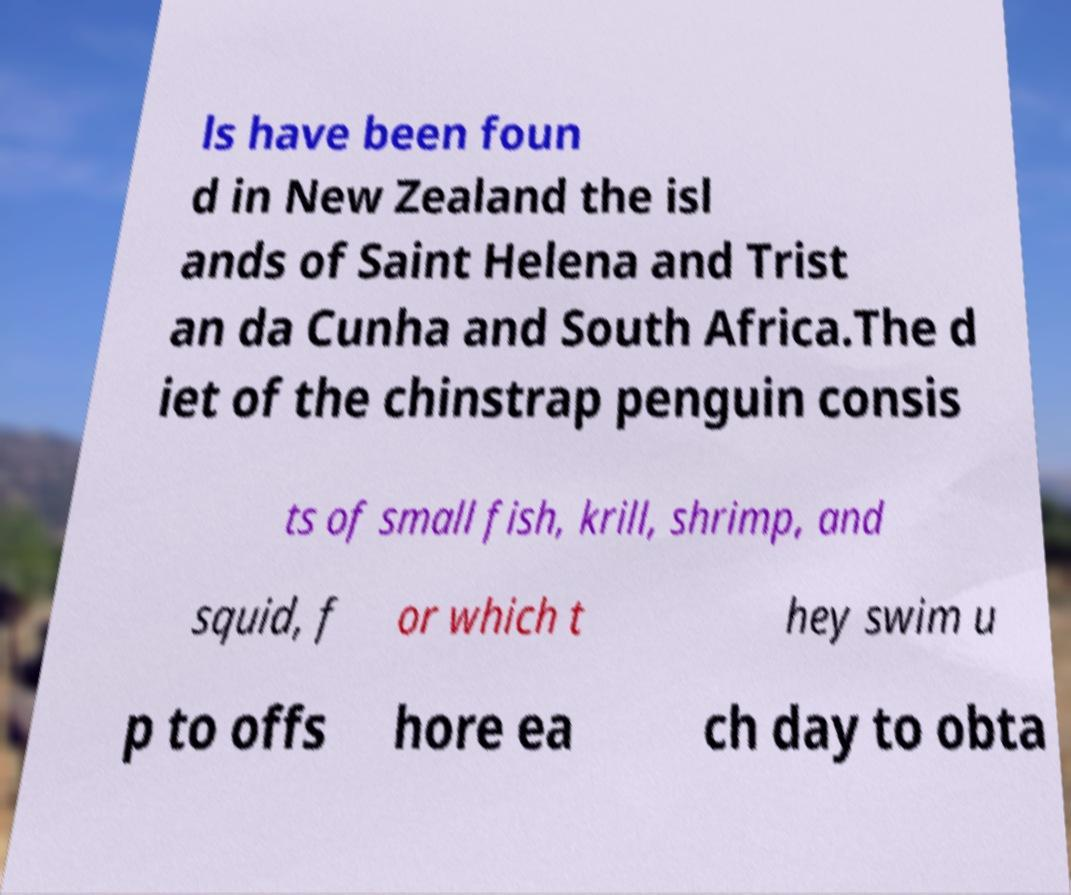I need the written content from this picture converted into text. Can you do that? ls have been foun d in New Zealand the isl ands of Saint Helena and Trist an da Cunha and South Africa.The d iet of the chinstrap penguin consis ts of small fish, krill, shrimp, and squid, f or which t hey swim u p to offs hore ea ch day to obta 